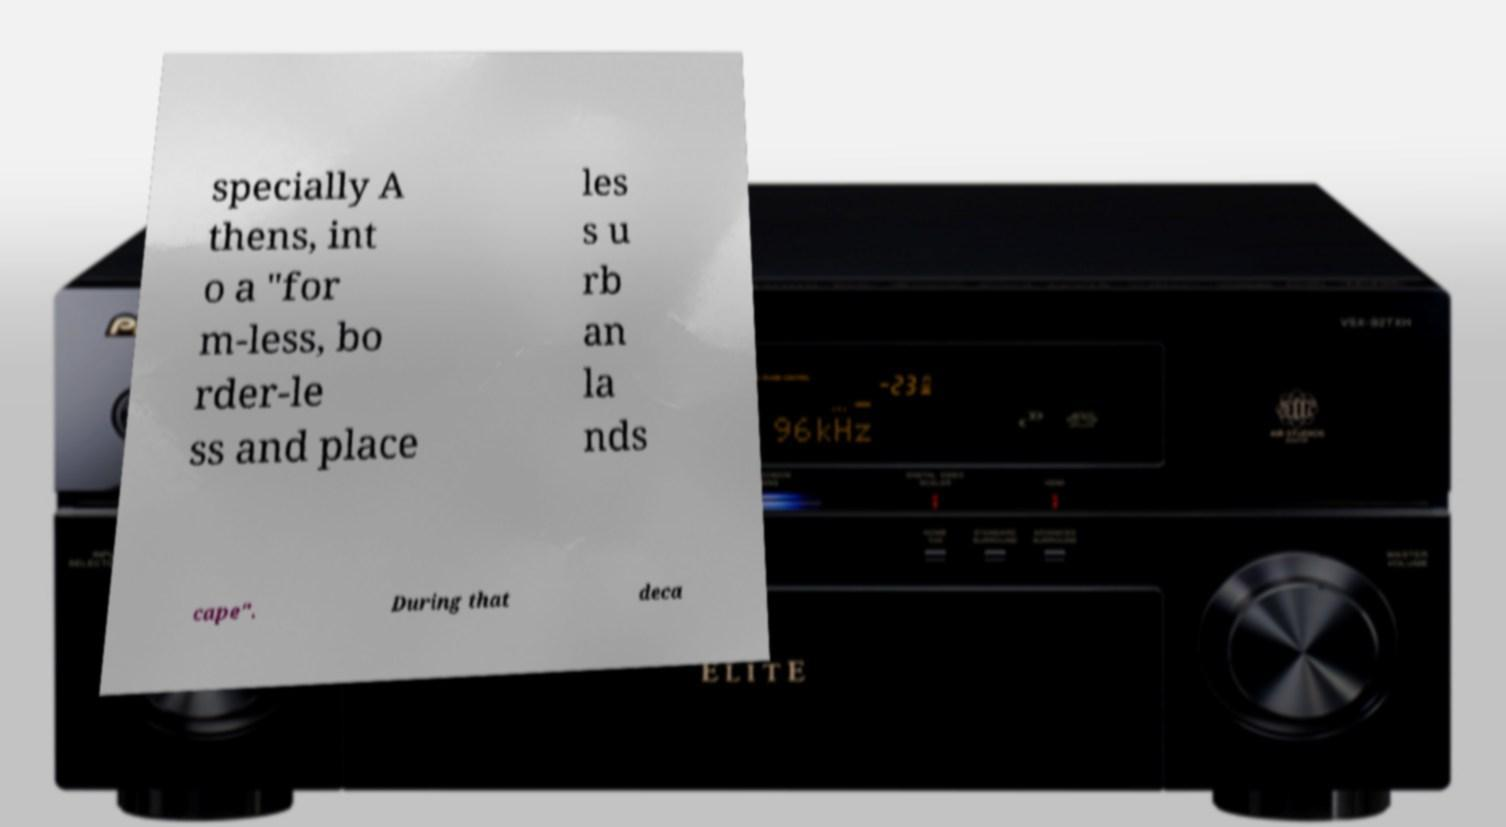I need the written content from this picture converted into text. Can you do that? specially A thens, int o a "for m-less, bo rder-le ss and place les s u rb an la nds cape". During that deca 